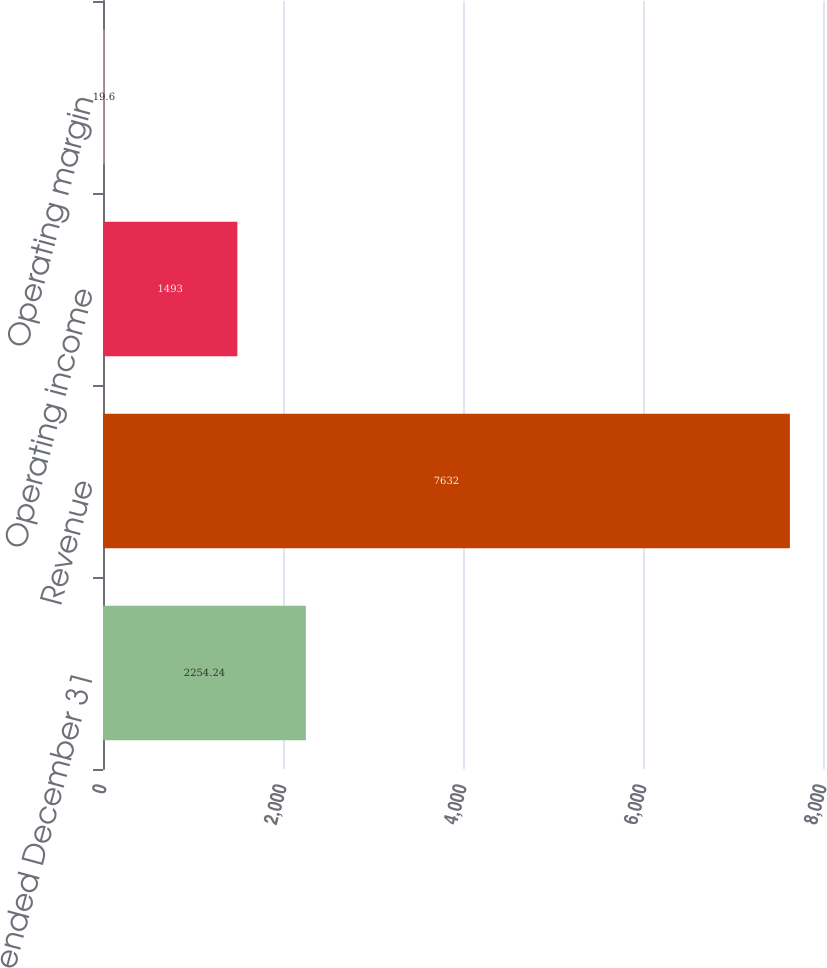Convert chart to OTSL. <chart><loc_0><loc_0><loc_500><loc_500><bar_chart><fcel>Years ended December 31<fcel>Revenue<fcel>Operating income<fcel>Operating margin<nl><fcel>2254.24<fcel>7632<fcel>1493<fcel>19.6<nl></chart> 